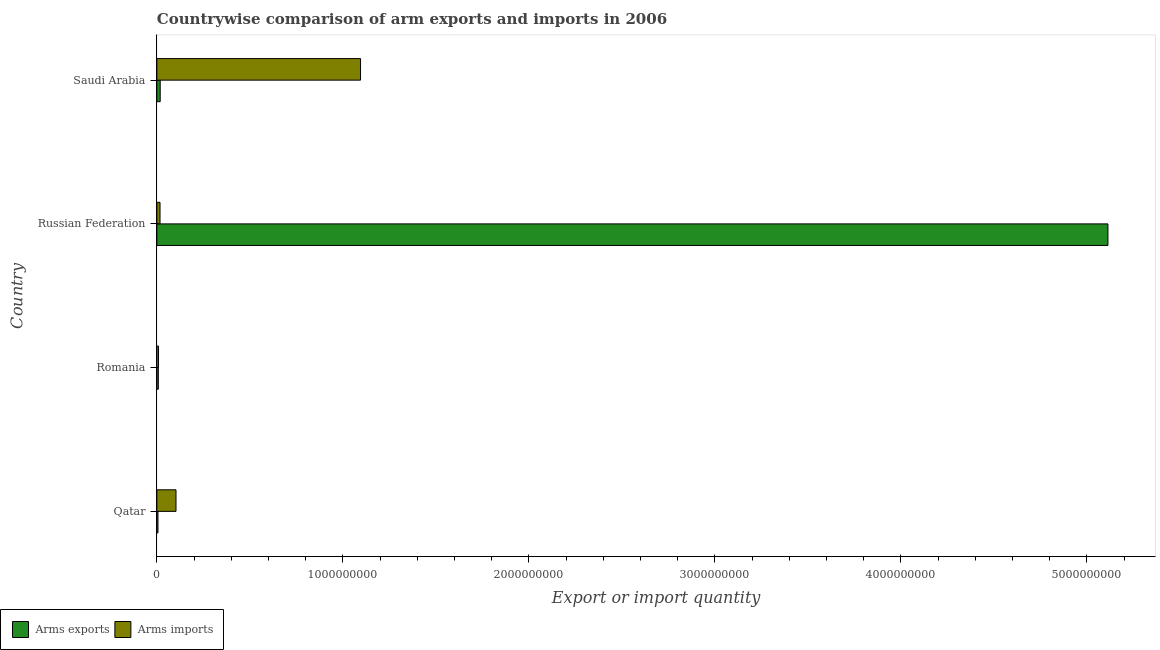What is the label of the 4th group of bars from the top?
Provide a succinct answer. Qatar. What is the arms imports in Saudi Arabia?
Ensure brevity in your answer.  1.10e+09. Across all countries, what is the maximum arms imports?
Keep it short and to the point. 1.10e+09. Across all countries, what is the minimum arms imports?
Offer a very short reply. 9.00e+06. In which country was the arms imports maximum?
Offer a very short reply. Saudi Arabia. In which country was the arms exports minimum?
Provide a short and direct response. Qatar. What is the total arms imports in the graph?
Your answer should be very brief. 1.22e+09. What is the difference between the arms imports in Romania and that in Russian Federation?
Provide a succinct answer. -8.00e+06. What is the difference between the arms imports in Russian Federation and the arms exports in Romania?
Provide a short and direct response. 9.00e+06. What is the average arms exports per country?
Your answer should be compact. 1.29e+09. What is the difference between the arms imports and arms exports in Russian Federation?
Your answer should be very brief. -5.10e+09. What is the ratio of the arms imports in Qatar to that in Saudi Arabia?
Offer a very short reply. 0.09. Is the arms imports in Romania less than that in Saudi Arabia?
Your response must be concise. Yes. Is the difference between the arms imports in Romania and Saudi Arabia greater than the difference between the arms exports in Romania and Saudi Arabia?
Give a very brief answer. No. What is the difference between the highest and the second highest arms exports?
Give a very brief answer. 5.10e+09. What is the difference between the highest and the lowest arms imports?
Your answer should be compact. 1.09e+09. In how many countries, is the arms imports greater than the average arms imports taken over all countries?
Keep it short and to the point. 1. Is the sum of the arms exports in Qatar and Russian Federation greater than the maximum arms imports across all countries?
Provide a short and direct response. Yes. What does the 2nd bar from the top in Qatar represents?
Make the answer very short. Arms exports. What does the 1st bar from the bottom in Romania represents?
Ensure brevity in your answer.  Arms exports. How many countries are there in the graph?
Offer a terse response. 4. What is the difference between two consecutive major ticks on the X-axis?
Ensure brevity in your answer.  1.00e+09. Are the values on the major ticks of X-axis written in scientific E-notation?
Ensure brevity in your answer.  No. Does the graph contain any zero values?
Your answer should be compact. No. Does the graph contain grids?
Provide a short and direct response. No. How are the legend labels stacked?
Your response must be concise. Horizontal. What is the title of the graph?
Offer a very short reply. Countrywise comparison of arm exports and imports in 2006. Does "Enforce a contract" appear as one of the legend labels in the graph?
Your answer should be very brief. No. What is the label or title of the X-axis?
Your response must be concise. Export or import quantity. What is the label or title of the Y-axis?
Offer a terse response. Country. What is the Export or import quantity of Arms imports in Qatar?
Provide a succinct answer. 1.03e+08. What is the Export or import quantity of Arms exports in Romania?
Your response must be concise. 8.00e+06. What is the Export or import quantity in Arms imports in Romania?
Offer a terse response. 9.00e+06. What is the Export or import quantity in Arms exports in Russian Federation?
Your response must be concise. 5.11e+09. What is the Export or import quantity in Arms imports in Russian Federation?
Your response must be concise. 1.70e+07. What is the Export or import quantity of Arms exports in Saudi Arabia?
Make the answer very short. 1.80e+07. What is the Export or import quantity of Arms imports in Saudi Arabia?
Give a very brief answer. 1.10e+09. Across all countries, what is the maximum Export or import quantity of Arms exports?
Make the answer very short. 5.11e+09. Across all countries, what is the maximum Export or import quantity of Arms imports?
Your response must be concise. 1.10e+09. Across all countries, what is the minimum Export or import quantity of Arms exports?
Offer a very short reply. 6.00e+06. Across all countries, what is the minimum Export or import quantity in Arms imports?
Provide a succinct answer. 9.00e+06. What is the total Export or import quantity of Arms exports in the graph?
Your response must be concise. 5.14e+09. What is the total Export or import quantity in Arms imports in the graph?
Provide a succinct answer. 1.22e+09. What is the difference between the Export or import quantity in Arms imports in Qatar and that in Romania?
Offer a terse response. 9.40e+07. What is the difference between the Export or import quantity of Arms exports in Qatar and that in Russian Federation?
Your response must be concise. -5.11e+09. What is the difference between the Export or import quantity in Arms imports in Qatar and that in Russian Federation?
Provide a short and direct response. 8.60e+07. What is the difference between the Export or import quantity of Arms exports in Qatar and that in Saudi Arabia?
Keep it short and to the point. -1.20e+07. What is the difference between the Export or import quantity of Arms imports in Qatar and that in Saudi Arabia?
Your answer should be very brief. -9.92e+08. What is the difference between the Export or import quantity in Arms exports in Romania and that in Russian Federation?
Provide a succinct answer. -5.10e+09. What is the difference between the Export or import quantity of Arms imports in Romania and that in Russian Federation?
Keep it short and to the point. -8.00e+06. What is the difference between the Export or import quantity of Arms exports in Romania and that in Saudi Arabia?
Your answer should be very brief. -1.00e+07. What is the difference between the Export or import quantity of Arms imports in Romania and that in Saudi Arabia?
Provide a short and direct response. -1.09e+09. What is the difference between the Export or import quantity in Arms exports in Russian Federation and that in Saudi Arabia?
Your answer should be compact. 5.10e+09. What is the difference between the Export or import quantity in Arms imports in Russian Federation and that in Saudi Arabia?
Provide a succinct answer. -1.08e+09. What is the difference between the Export or import quantity of Arms exports in Qatar and the Export or import quantity of Arms imports in Romania?
Keep it short and to the point. -3.00e+06. What is the difference between the Export or import quantity in Arms exports in Qatar and the Export or import quantity in Arms imports in Russian Federation?
Keep it short and to the point. -1.10e+07. What is the difference between the Export or import quantity in Arms exports in Qatar and the Export or import quantity in Arms imports in Saudi Arabia?
Give a very brief answer. -1.09e+09. What is the difference between the Export or import quantity of Arms exports in Romania and the Export or import quantity of Arms imports in Russian Federation?
Make the answer very short. -9.00e+06. What is the difference between the Export or import quantity of Arms exports in Romania and the Export or import quantity of Arms imports in Saudi Arabia?
Keep it short and to the point. -1.09e+09. What is the difference between the Export or import quantity of Arms exports in Russian Federation and the Export or import quantity of Arms imports in Saudi Arabia?
Make the answer very short. 4.02e+09. What is the average Export or import quantity in Arms exports per country?
Offer a terse response. 1.29e+09. What is the average Export or import quantity of Arms imports per country?
Your answer should be very brief. 3.06e+08. What is the difference between the Export or import quantity of Arms exports and Export or import quantity of Arms imports in Qatar?
Ensure brevity in your answer.  -9.70e+07. What is the difference between the Export or import quantity in Arms exports and Export or import quantity in Arms imports in Russian Federation?
Provide a short and direct response. 5.10e+09. What is the difference between the Export or import quantity of Arms exports and Export or import quantity of Arms imports in Saudi Arabia?
Ensure brevity in your answer.  -1.08e+09. What is the ratio of the Export or import quantity of Arms imports in Qatar to that in Romania?
Your answer should be compact. 11.44. What is the ratio of the Export or import quantity of Arms exports in Qatar to that in Russian Federation?
Your answer should be very brief. 0. What is the ratio of the Export or import quantity of Arms imports in Qatar to that in Russian Federation?
Offer a terse response. 6.06. What is the ratio of the Export or import quantity in Arms exports in Qatar to that in Saudi Arabia?
Your response must be concise. 0.33. What is the ratio of the Export or import quantity of Arms imports in Qatar to that in Saudi Arabia?
Provide a short and direct response. 0.09. What is the ratio of the Export or import quantity in Arms exports in Romania to that in Russian Federation?
Your answer should be compact. 0. What is the ratio of the Export or import quantity in Arms imports in Romania to that in Russian Federation?
Provide a short and direct response. 0.53. What is the ratio of the Export or import quantity in Arms exports in Romania to that in Saudi Arabia?
Ensure brevity in your answer.  0.44. What is the ratio of the Export or import quantity of Arms imports in Romania to that in Saudi Arabia?
Offer a very short reply. 0.01. What is the ratio of the Export or import quantity of Arms exports in Russian Federation to that in Saudi Arabia?
Your answer should be compact. 284.06. What is the ratio of the Export or import quantity in Arms imports in Russian Federation to that in Saudi Arabia?
Offer a terse response. 0.02. What is the difference between the highest and the second highest Export or import quantity of Arms exports?
Your response must be concise. 5.10e+09. What is the difference between the highest and the second highest Export or import quantity of Arms imports?
Provide a short and direct response. 9.92e+08. What is the difference between the highest and the lowest Export or import quantity in Arms exports?
Provide a short and direct response. 5.11e+09. What is the difference between the highest and the lowest Export or import quantity in Arms imports?
Make the answer very short. 1.09e+09. 